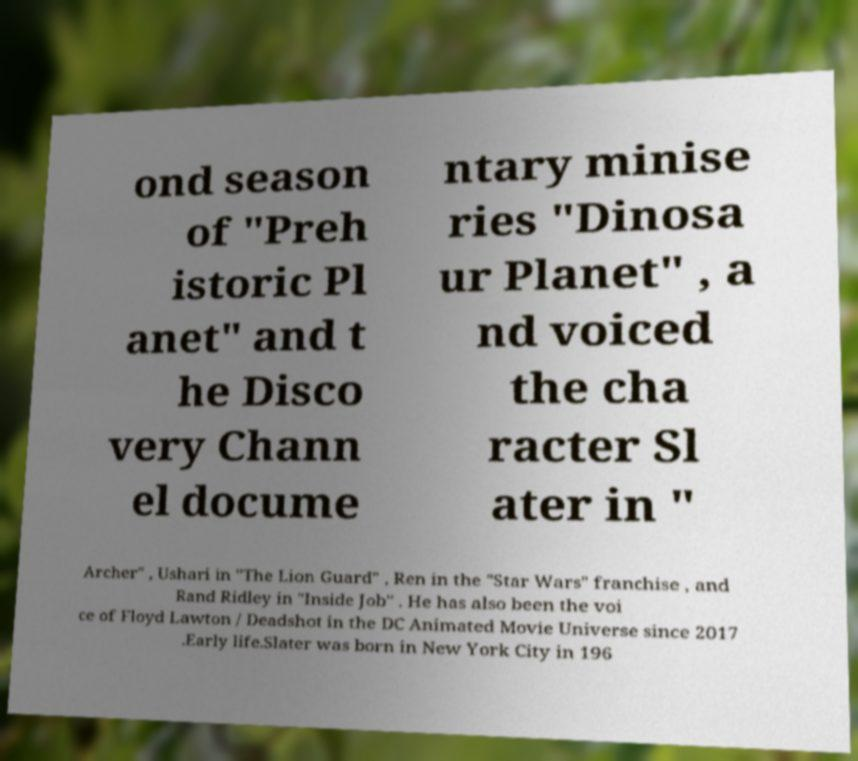Can you read and provide the text displayed in the image?This photo seems to have some interesting text. Can you extract and type it out for me? ond season of "Preh istoric Pl anet" and t he Disco very Chann el docume ntary minise ries "Dinosa ur Planet" , a nd voiced the cha racter Sl ater in " Archer" , Ushari in "The Lion Guard" , Ren in the "Star Wars" franchise , and Rand Ridley in "Inside Job" . He has also been the voi ce of Floyd Lawton / Deadshot in the DC Animated Movie Universe since 2017 .Early life.Slater was born in New York City in 196 